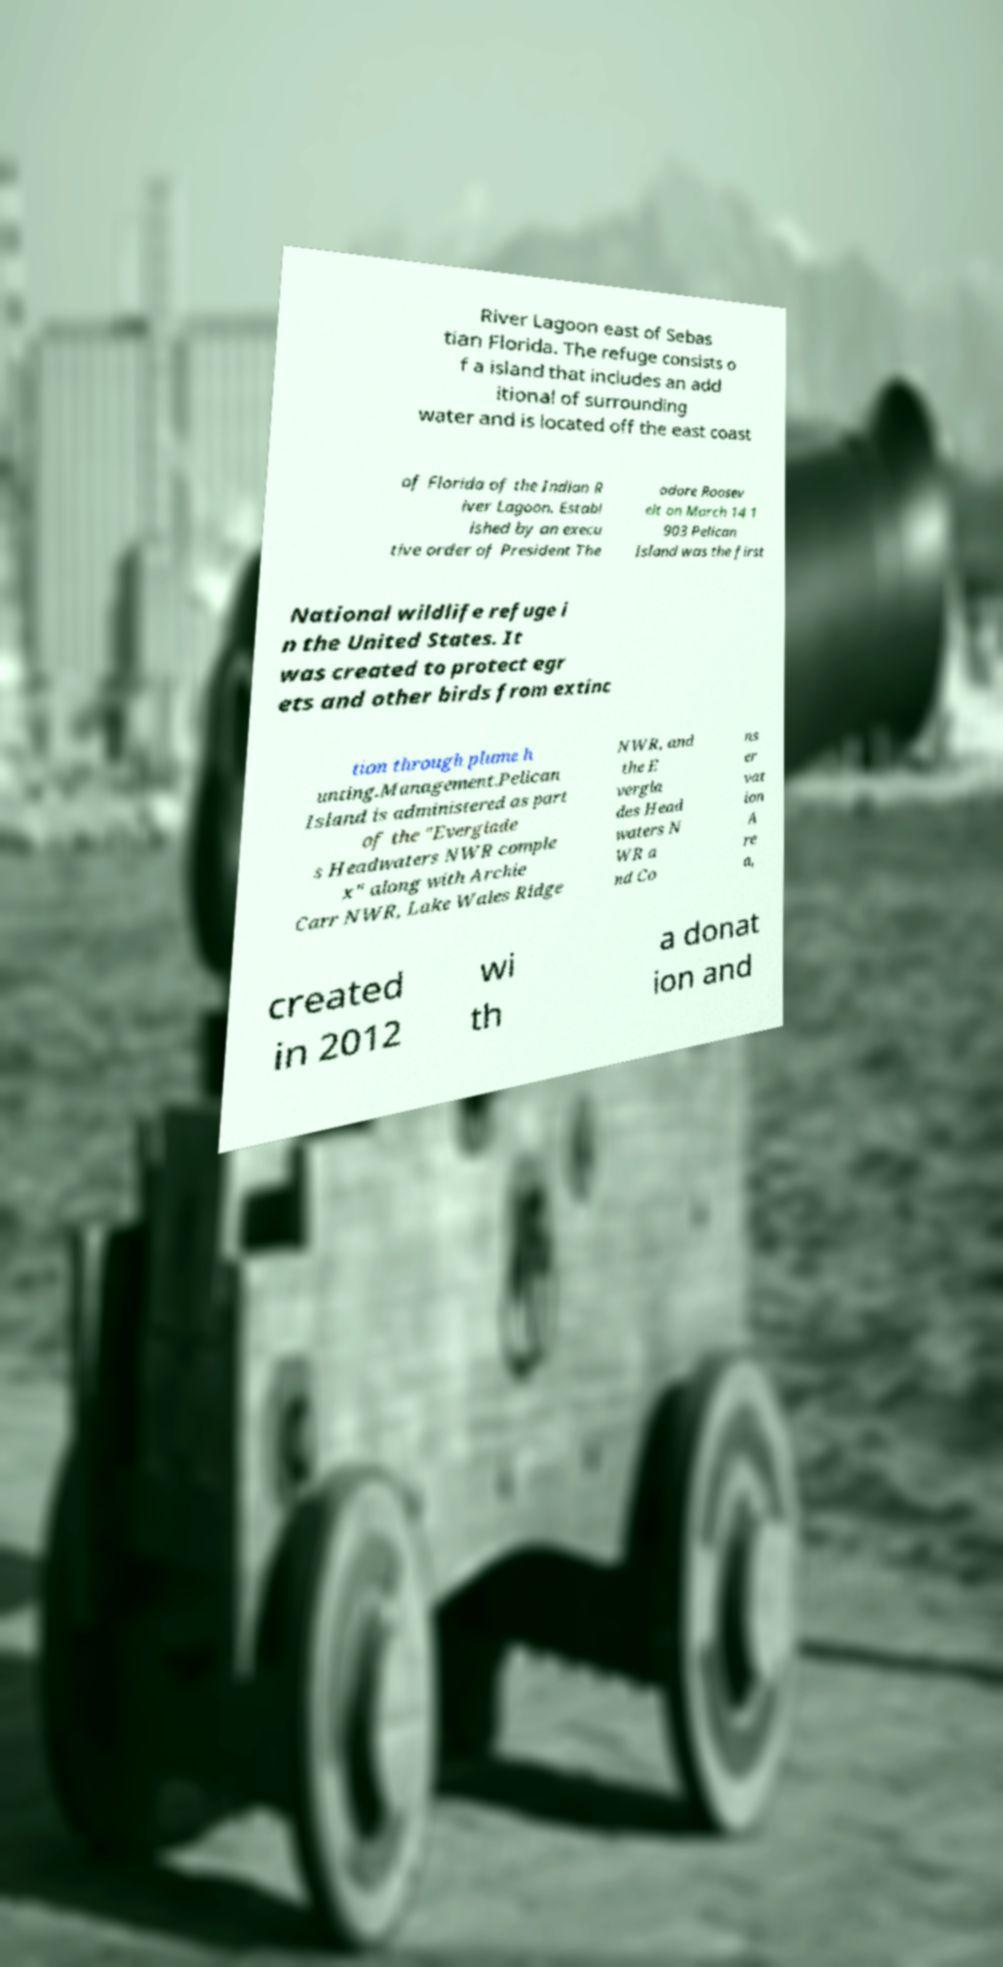What messages or text are displayed in this image? I need them in a readable, typed format. River Lagoon east of Sebas tian Florida. The refuge consists o f a island that includes an add itional of surrounding water and is located off the east coast of Florida of the Indian R iver Lagoon. Establ ished by an execu tive order of President The odore Roosev elt on March 14 1 903 Pelican Island was the first National wildlife refuge i n the United States. It was created to protect egr ets and other birds from extinc tion through plume h unting.Management.Pelican Island is administered as part of the "Everglade s Headwaters NWR comple x" along with Archie Carr NWR, Lake Wales Ridge NWR, and the E vergla des Head waters N WR a nd Co ns er vat ion A re a, created in 2012 wi th a donat ion and 